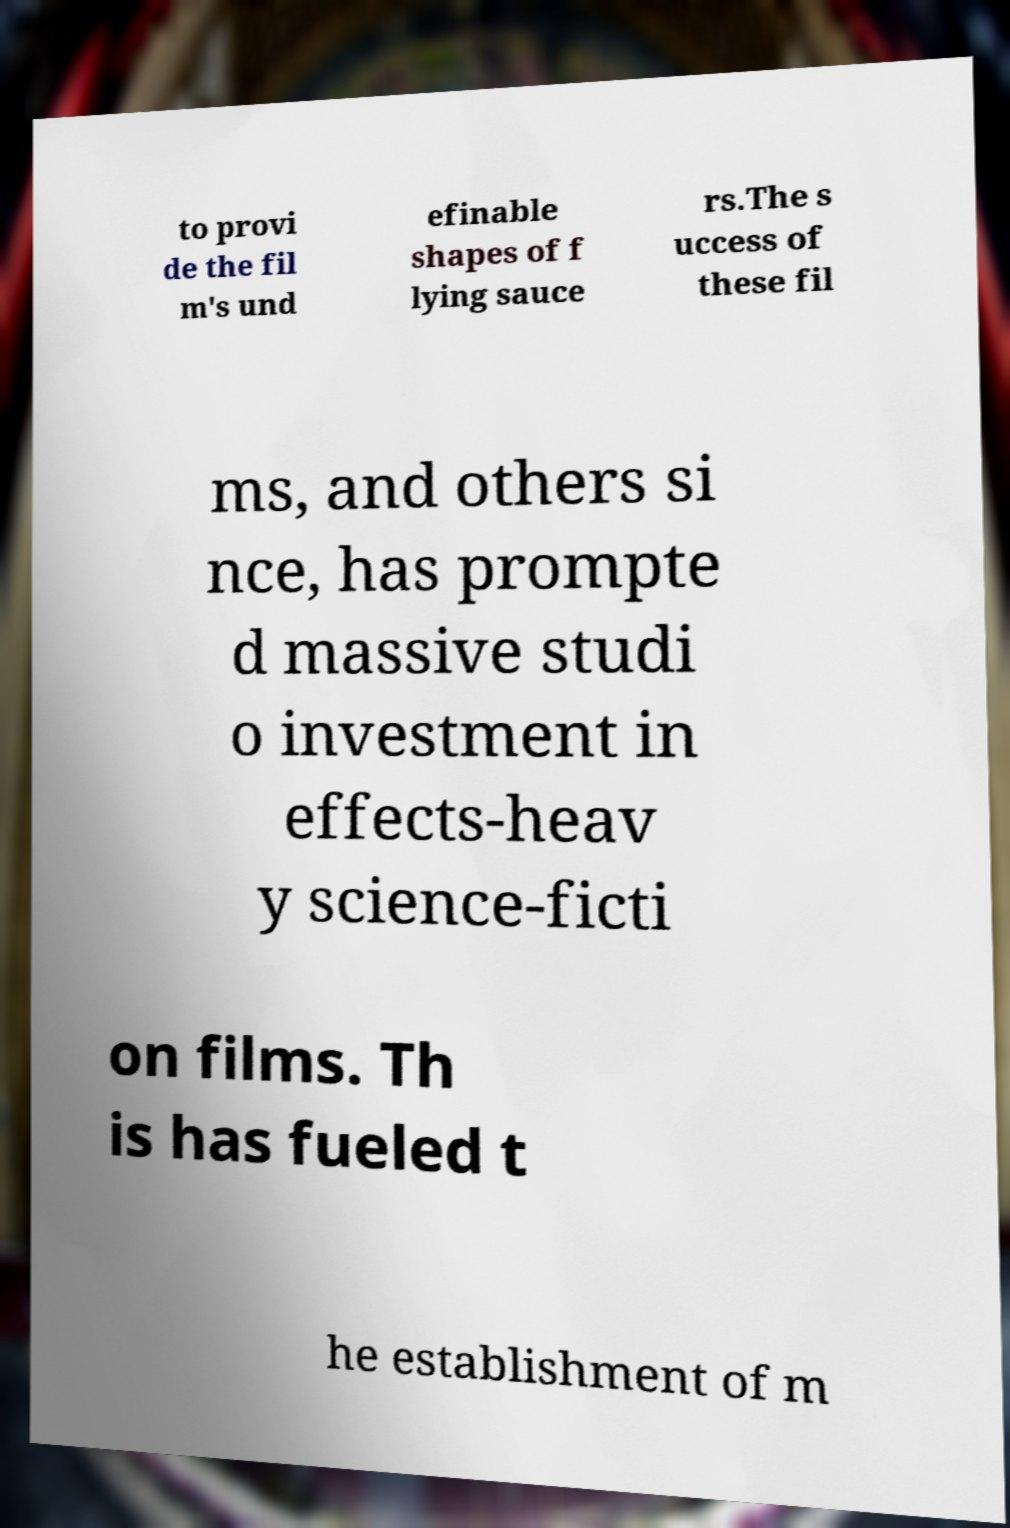Could you extract and type out the text from this image? to provi de the fil m's und efinable shapes of f lying sauce rs.The s uccess of these fil ms, and others si nce, has prompte d massive studi o investment in effects-heav y science-ficti on films. Th is has fueled t he establishment of m 